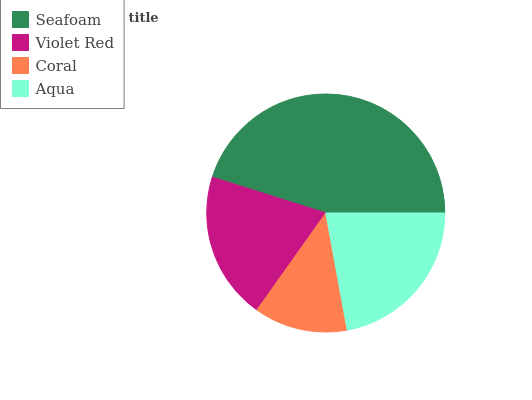Is Coral the minimum?
Answer yes or no. Yes. Is Seafoam the maximum?
Answer yes or no. Yes. Is Violet Red the minimum?
Answer yes or no. No. Is Violet Red the maximum?
Answer yes or no. No. Is Seafoam greater than Violet Red?
Answer yes or no. Yes. Is Violet Red less than Seafoam?
Answer yes or no. Yes. Is Violet Red greater than Seafoam?
Answer yes or no. No. Is Seafoam less than Violet Red?
Answer yes or no. No. Is Aqua the high median?
Answer yes or no. Yes. Is Violet Red the low median?
Answer yes or no. Yes. Is Seafoam the high median?
Answer yes or no. No. Is Aqua the low median?
Answer yes or no. No. 